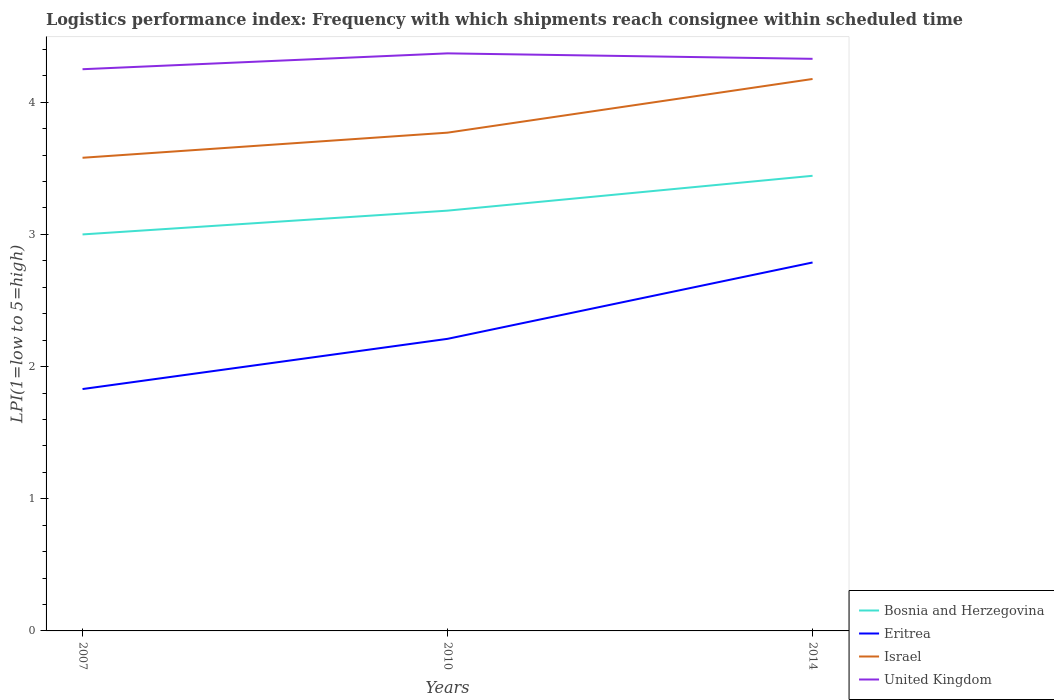Does the line corresponding to Eritrea intersect with the line corresponding to Bosnia and Herzegovina?
Ensure brevity in your answer.  No. Is the number of lines equal to the number of legend labels?
Offer a terse response. Yes. What is the total logistics performance index in Bosnia and Herzegovina in the graph?
Offer a terse response. -0.44. What is the difference between the highest and the second highest logistics performance index in Israel?
Offer a terse response. 0.6. What is the difference between the highest and the lowest logistics performance index in Eritrea?
Keep it short and to the point. 1. How many lines are there?
Your response must be concise. 4. How many years are there in the graph?
Offer a terse response. 3. What is the difference between two consecutive major ticks on the Y-axis?
Your answer should be compact. 1. Does the graph contain any zero values?
Your answer should be compact. No. How many legend labels are there?
Keep it short and to the point. 4. What is the title of the graph?
Your answer should be very brief. Logistics performance index: Frequency with which shipments reach consignee within scheduled time. What is the label or title of the Y-axis?
Make the answer very short. LPI(1=low to 5=high). What is the LPI(1=low to 5=high) of Bosnia and Herzegovina in 2007?
Provide a succinct answer. 3. What is the LPI(1=low to 5=high) in Eritrea in 2007?
Your answer should be compact. 1.83. What is the LPI(1=low to 5=high) in Israel in 2007?
Make the answer very short. 3.58. What is the LPI(1=low to 5=high) in United Kingdom in 2007?
Provide a succinct answer. 4.25. What is the LPI(1=low to 5=high) of Bosnia and Herzegovina in 2010?
Offer a terse response. 3.18. What is the LPI(1=low to 5=high) in Eritrea in 2010?
Make the answer very short. 2.21. What is the LPI(1=low to 5=high) in Israel in 2010?
Keep it short and to the point. 3.77. What is the LPI(1=low to 5=high) in United Kingdom in 2010?
Make the answer very short. 4.37. What is the LPI(1=low to 5=high) of Bosnia and Herzegovina in 2014?
Offer a terse response. 3.44. What is the LPI(1=low to 5=high) in Eritrea in 2014?
Ensure brevity in your answer.  2.79. What is the LPI(1=low to 5=high) in Israel in 2014?
Provide a succinct answer. 4.18. What is the LPI(1=low to 5=high) of United Kingdom in 2014?
Your response must be concise. 4.33. Across all years, what is the maximum LPI(1=low to 5=high) in Bosnia and Herzegovina?
Your answer should be very brief. 3.44. Across all years, what is the maximum LPI(1=low to 5=high) of Eritrea?
Offer a very short reply. 2.79. Across all years, what is the maximum LPI(1=low to 5=high) of Israel?
Provide a succinct answer. 4.18. Across all years, what is the maximum LPI(1=low to 5=high) of United Kingdom?
Make the answer very short. 4.37. Across all years, what is the minimum LPI(1=low to 5=high) in Eritrea?
Ensure brevity in your answer.  1.83. Across all years, what is the minimum LPI(1=low to 5=high) in Israel?
Your answer should be compact. 3.58. Across all years, what is the minimum LPI(1=low to 5=high) in United Kingdom?
Your response must be concise. 4.25. What is the total LPI(1=low to 5=high) in Bosnia and Herzegovina in the graph?
Your response must be concise. 9.62. What is the total LPI(1=low to 5=high) of Eritrea in the graph?
Your response must be concise. 6.83. What is the total LPI(1=low to 5=high) in Israel in the graph?
Your answer should be very brief. 11.53. What is the total LPI(1=low to 5=high) of United Kingdom in the graph?
Your answer should be compact. 12.95. What is the difference between the LPI(1=low to 5=high) of Bosnia and Herzegovina in 2007 and that in 2010?
Provide a short and direct response. -0.18. What is the difference between the LPI(1=low to 5=high) of Eritrea in 2007 and that in 2010?
Keep it short and to the point. -0.38. What is the difference between the LPI(1=low to 5=high) of Israel in 2007 and that in 2010?
Make the answer very short. -0.19. What is the difference between the LPI(1=low to 5=high) in United Kingdom in 2007 and that in 2010?
Your response must be concise. -0.12. What is the difference between the LPI(1=low to 5=high) of Bosnia and Herzegovina in 2007 and that in 2014?
Your answer should be compact. -0.44. What is the difference between the LPI(1=low to 5=high) of Eritrea in 2007 and that in 2014?
Your response must be concise. -0.96. What is the difference between the LPI(1=low to 5=high) of Israel in 2007 and that in 2014?
Provide a succinct answer. -0.6. What is the difference between the LPI(1=low to 5=high) in United Kingdom in 2007 and that in 2014?
Your answer should be very brief. -0.08. What is the difference between the LPI(1=low to 5=high) of Bosnia and Herzegovina in 2010 and that in 2014?
Ensure brevity in your answer.  -0.26. What is the difference between the LPI(1=low to 5=high) in Eritrea in 2010 and that in 2014?
Your response must be concise. -0.58. What is the difference between the LPI(1=low to 5=high) of Israel in 2010 and that in 2014?
Offer a terse response. -0.41. What is the difference between the LPI(1=low to 5=high) in United Kingdom in 2010 and that in 2014?
Provide a short and direct response. 0.04. What is the difference between the LPI(1=low to 5=high) in Bosnia and Herzegovina in 2007 and the LPI(1=low to 5=high) in Eritrea in 2010?
Provide a short and direct response. 0.79. What is the difference between the LPI(1=low to 5=high) of Bosnia and Herzegovina in 2007 and the LPI(1=low to 5=high) of Israel in 2010?
Your response must be concise. -0.77. What is the difference between the LPI(1=low to 5=high) in Bosnia and Herzegovina in 2007 and the LPI(1=low to 5=high) in United Kingdom in 2010?
Keep it short and to the point. -1.37. What is the difference between the LPI(1=low to 5=high) in Eritrea in 2007 and the LPI(1=low to 5=high) in Israel in 2010?
Offer a very short reply. -1.94. What is the difference between the LPI(1=low to 5=high) in Eritrea in 2007 and the LPI(1=low to 5=high) in United Kingdom in 2010?
Provide a succinct answer. -2.54. What is the difference between the LPI(1=low to 5=high) in Israel in 2007 and the LPI(1=low to 5=high) in United Kingdom in 2010?
Provide a succinct answer. -0.79. What is the difference between the LPI(1=low to 5=high) in Bosnia and Herzegovina in 2007 and the LPI(1=low to 5=high) in Eritrea in 2014?
Offer a terse response. 0.21. What is the difference between the LPI(1=low to 5=high) of Bosnia and Herzegovina in 2007 and the LPI(1=low to 5=high) of Israel in 2014?
Ensure brevity in your answer.  -1.18. What is the difference between the LPI(1=low to 5=high) of Bosnia and Herzegovina in 2007 and the LPI(1=low to 5=high) of United Kingdom in 2014?
Your answer should be very brief. -1.33. What is the difference between the LPI(1=low to 5=high) of Eritrea in 2007 and the LPI(1=low to 5=high) of Israel in 2014?
Ensure brevity in your answer.  -2.35. What is the difference between the LPI(1=low to 5=high) of Eritrea in 2007 and the LPI(1=low to 5=high) of United Kingdom in 2014?
Keep it short and to the point. -2.5. What is the difference between the LPI(1=low to 5=high) of Israel in 2007 and the LPI(1=low to 5=high) of United Kingdom in 2014?
Keep it short and to the point. -0.75. What is the difference between the LPI(1=low to 5=high) in Bosnia and Herzegovina in 2010 and the LPI(1=low to 5=high) in Eritrea in 2014?
Your answer should be compact. 0.39. What is the difference between the LPI(1=low to 5=high) in Bosnia and Herzegovina in 2010 and the LPI(1=low to 5=high) in Israel in 2014?
Keep it short and to the point. -1. What is the difference between the LPI(1=low to 5=high) in Bosnia and Herzegovina in 2010 and the LPI(1=low to 5=high) in United Kingdom in 2014?
Your answer should be compact. -1.15. What is the difference between the LPI(1=low to 5=high) in Eritrea in 2010 and the LPI(1=low to 5=high) in Israel in 2014?
Your answer should be compact. -1.97. What is the difference between the LPI(1=low to 5=high) in Eritrea in 2010 and the LPI(1=low to 5=high) in United Kingdom in 2014?
Ensure brevity in your answer.  -2.12. What is the difference between the LPI(1=low to 5=high) in Israel in 2010 and the LPI(1=low to 5=high) in United Kingdom in 2014?
Offer a terse response. -0.56. What is the average LPI(1=low to 5=high) in Bosnia and Herzegovina per year?
Your answer should be very brief. 3.21. What is the average LPI(1=low to 5=high) of Eritrea per year?
Provide a succinct answer. 2.28. What is the average LPI(1=low to 5=high) of Israel per year?
Your answer should be compact. 3.84. What is the average LPI(1=low to 5=high) in United Kingdom per year?
Provide a succinct answer. 4.32. In the year 2007, what is the difference between the LPI(1=low to 5=high) of Bosnia and Herzegovina and LPI(1=low to 5=high) of Eritrea?
Your response must be concise. 1.17. In the year 2007, what is the difference between the LPI(1=low to 5=high) in Bosnia and Herzegovina and LPI(1=low to 5=high) in Israel?
Provide a short and direct response. -0.58. In the year 2007, what is the difference between the LPI(1=low to 5=high) of Bosnia and Herzegovina and LPI(1=low to 5=high) of United Kingdom?
Offer a very short reply. -1.25. In the year 2007, what is the difference between the LPI(1=low to 5=high) of Eritrea and LPI(1=low to 5=high) of Israel?
Your response must be concise. -1.75. In the year 2007, what is the difference between the LPI(1=low to 5=high) of Eritrea and LPI(1=low to 5=high) of United Kingdom?
Offer a terse response. -2.42. In the year 2007, what is the difference between the LPI(1=low to 5=high) in Israel and LPI(1=low to 5=high) in United Kingdom?
Provide a succinct answer. -0.67. In the year 2010, what is the difference between the LPI(1=low to 5=high) in Bosnia and Herzegovina and LPI(1=low to 5=high) in Israel?
Ensure brevity in your answer.  -0.59. In the year 2010, what is the difference between the LPI(1=low to 5=high) in Bosnia and Herzegovina and LPI(1=low to 5=high) in United Kingdom?
Your answer should be very brief. -1.19. In the year 2010, what is the difference between the LPI(1=low to 5=high) in Eritrea and LPI(1=low to 5=high) in Israel?
Ensure brevity in your answer.  -1.56. In the year 2010, what is the difference between the LPI(1=low to 5=high) in Eritrea and LPI(1=low to 5=high) in United Kingdom?
Offer a very short reply. -2.16. In the year 2014, what is the difference between the LPI(1=low to 5=high) of Bosnia and Herzegovina and LPI(1=low to 5=high) of Eritrea?
Keep it short and to the point. 0.66. In the year 2014, what is the difference between the LPI(1=low to 5=high) in Bosnia and Herzegovina and LPI(1=low to 5=high) in Israel?
Make the answer very short. -0.73. In the year 2014, what is the difference between the LPI(1=low to 5=high) in Bosnia and Herzegovina and LPI(1=low to 5=high) in United Kingdom?
Your answer should be compact. -0.88. In the year 2014, what is the difference between the LPI(1=low to 5=high) in Eritrea and LPI(1=low to 5=high) in Israel?
Offer a terse response. -1.39. In the year 2014, what is the difference between the LPI(1=low to 5=high) in Eritrea and LPI(1=low to 5=high) in United Kingdom?
Keep it short and to the point. -1.54. In the year 2014, what is the difference between the LPI(1=low to 5=high) in Israel and LPI(1=low to 5=high) in United Kingdom?
Your response must be concise. -0.15. What is the ratio of the LPI(1=low to 5=high) in Bosnia and Herzegovina in 2007 to that in 2010?
Give a very brief answer. 0.94. What is the ratio of the LPI(1=low to 5=high) of Eritrea in 2007 to that in 2010?
Provide a short and direct response. 0.83. What is the ratio of the LPI(1=low to 5=high) in Israel in 2007 to that in 2010?
Keep it short and to the point. 0.95. What is the ratio of the LPI(1=low to 5=high) of United Kingdom in 2007 to that in 2010?
Keep it short and to the point. 0.97. What is the ratio of the LPI(1=low to 5=high) in Bosnia and Herzegovina in 2007 to that in 2014?
Offer a very short reply. 0.87. What is the ratio of the LPI(1=low to 5=high) in Eritrea in 2007 to that in 2014?
Your response must be concise. 0.66. What is the ratio of the LPI(1=low to 5=high) in Israel in 2007 to that in 2014?
Offer a very short reply. 0.86. What is the ratio of the LPI(1=low to 5=high) of United Kingdom in 2007 to that in 2014?
Give a very brief answer. 0.98. What is the ratio of the LPI(1=low to 5=high) of Bosnia and Herzegovina in 2010 to that in 2014?
Your answer should be very brief. 0.92. What is the ratio of the LPI(1=low to 5=high) of Eritrea in 2010 to that in 2014?
Provide a short and direct response. 0.79. What is the ratio of the LPI(1=low to 5=high) in Israel in 2010 to that in 2014?
Ensure brevity in your answer.  0.9. What is the ratio of the LPI(1=low to 5=high) of United Kingdom in 2010 to that in 2014?
Your response must be concise. 1.01. What is the difference between the highest and the second highest LPI(1=low to 5=high) of Bosnia and Herzegovina?
Your answer should be very brief. 0.26. What is the difference between the highest and the second highest LPI(1=low to 5=high) in Eritrea?
Your answer should be very brief. 0.58. What is the difference between the highest and the second highest LPI(1=low to 5=high) in Israel?
Your response must be concise. 0.41. What is the difference between the highest and the second highest LPI(1=low to 5=high) of United Kingdom?
Provide a succinct answer. 0.04. What is the difference between the highest and the lowest LPI(1=low to 5=high) of Bosnia and Herzegovina?
Provide a short and direct response. 0.44. What is the difference between the highest and the lowest LPI(1=low to 5=high) of Eritrea?
Ensure brevity in your answer.  0.96. What is the difference between the highest and the lowest LPI(1=low to 5=high) of Israel?
Offer a very short reply. 0.6. What is the difference between the highest and the lowest LPI(1=low to 5=high) of United Kingdom?
Your answer should be compact. 0.12. 